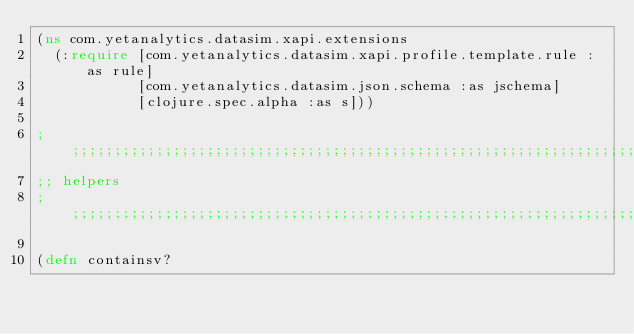Convert code to text. <code><loc_0><loc_0><loc_500><loc_500><_Clojure_>(ns com.yetanalytics.datasim.xapi.extensions
  (:require [com.yetanalytics.datasim.xapi.profile.template.rule :as rule]
            [com.yetanalytics.datasim.json.schema :as jschema]
            [clojure.spec.alpha :as s]))

;;;;;;;;;;;;;;;;;;;;;;;;;;;;;;;;;;;;;;;;;;;;;;;;;;;;;;;;;;;;;;;;;;;;;;;;;;;;;;;;;
;; helpers
;;;;;;;;;;;;;;;;;;;;;;;;;;;;;;;;;;;;;;;;;;;;;;;;;;;;;;;;;;;;;;;;;;;;;;;;;;;;;;;;;

(defn containsv?</code> 